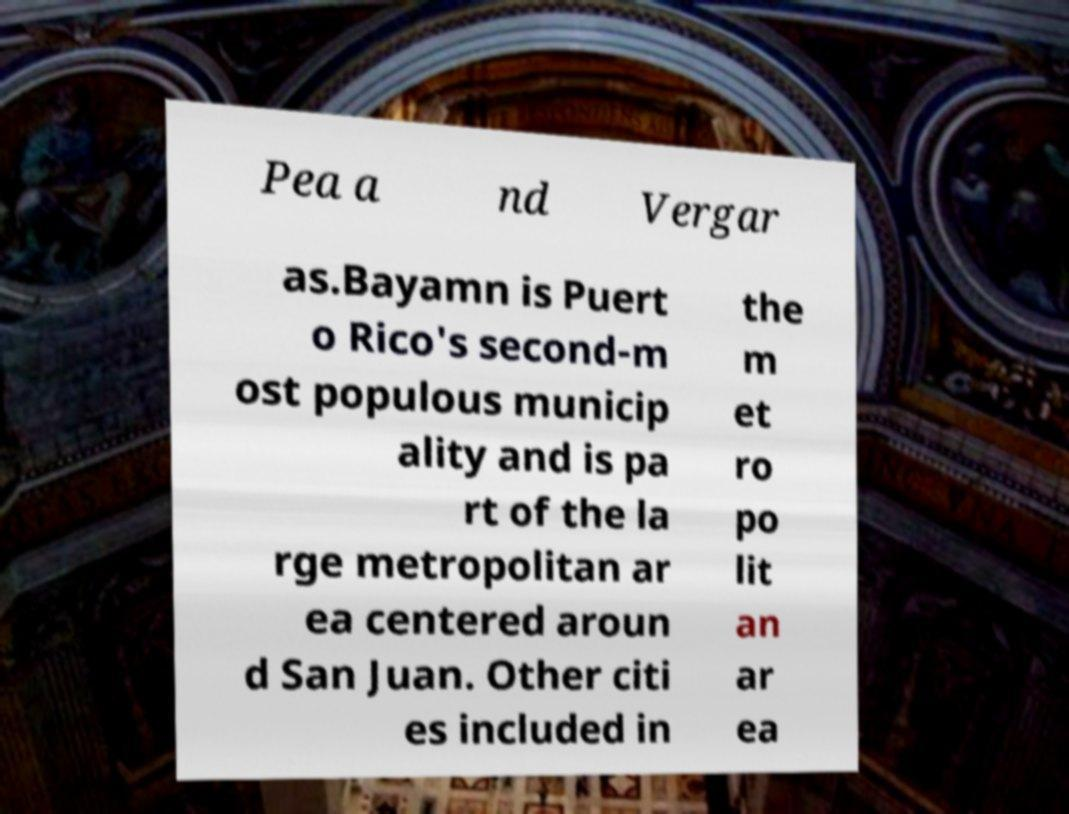I need the written content from this picture converted into text. Can you do that? Pea a nd Vergar as.Bayamn is Puert o Rico's second-m ost populous municip ality and is pa rt of the la rge metropolitan ar ea centered aroun d San Juan. Other citi es included in the m et ro po lit an ar ea 